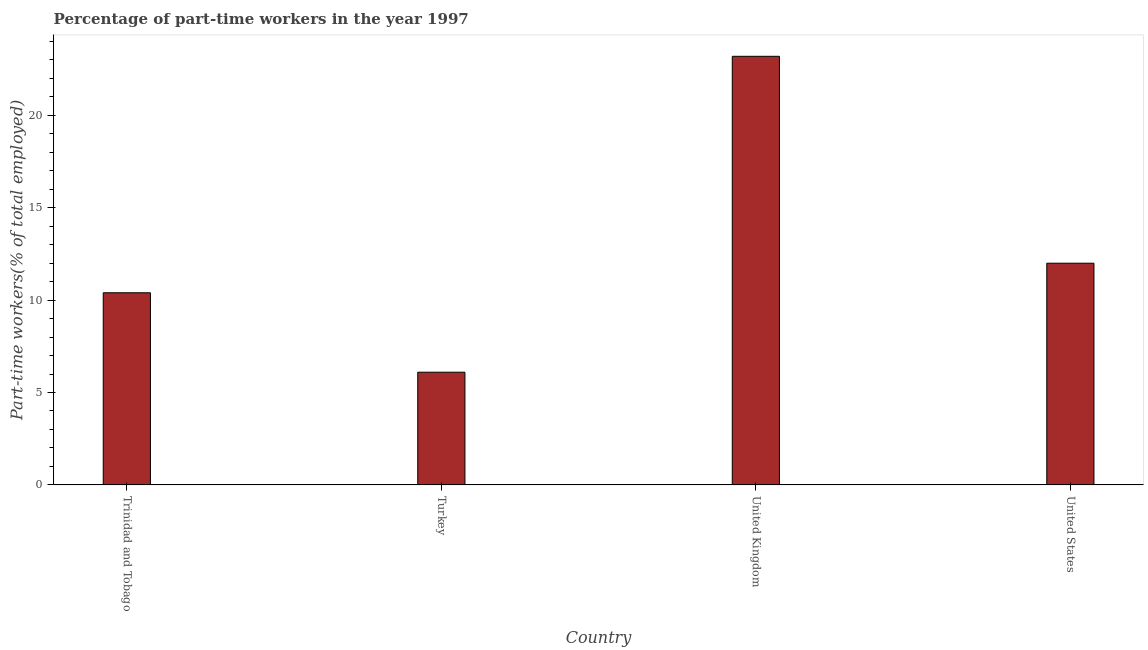Does the graph contain any zero values?
Keep it short and to the point. No. Does the graph contain grids?
Your answer should be very brief. No. What is the title of the graph?
Make the answer very short. Percentage of part-time workers in the year 1997. What is the label or title of the X-axis?
Provide a short and direct response. Country. What is the label or title of the Y-axis?
Give a very brief answer. Part-time workers(% of total employed). What is the percentage of part-time workers in Trinidad and Tobago?
Keep it short and to the point. 10.4. Across all countries, what is the maximum percentage of part-time workers?
Ensure brevity in your answer.  23.2. Across all countries, what is the minimum percentage of part-time workers?
Provide a short and direct response. 6.1. In which country was the percentage of part-time workers maximum?
Keep it short and to the point. United Kingdom. In which country was the percentage of part-time workers minimum?
Your answer should be very brief. Turkey. What is the sum of the percentage of part-time workers?
Offer a very short reply. 51.7. What is the average percentage of part-time workers per country?
Your response must be concise. 12.93. What is the median percentage of part-time workers?
Your answer should be compact. 11.2. What is the ratio of the percentage of part-time workers in Turkey to that in United States?
Your response must be concise. 0.51. Is the percentage of part-time workers in Turkey less than that in United Kingdom?
Keep it short and to the point. Yes. Is the difference between the percentage of part-time workers in Turkey and United Kingdom greater than the difference between any two countries?
Your response must be concise. Yes. What is the difference between the highest and the second highest percentage of part-time workers?
Provide a short and direct response. 11.2. Is the sum of the percentage of part-time workers in Turkey and United Kingdom greater than the maximum percentage of part-time workers across all countries?
Ensure brevity in your answer.  Yes. What is the difference between the highest and the lowest percentage of part-time workers?
Provide a short and direct response. 17.1. In how many countries, is the percentage of part-time workers greater than the average percentage of part-time workers taken over all countries?
Provide a short and direct response. 1. Are all the bars in the graph horizontal?
Offer a terse response. No. What is the Part-time workers(% of total employed) of Trinidad and Tobago?
Offer a terse response. 10.4. What is the Part-time workers(% of total employed) in Turkey?
Provide a succinct answer. 6.1. What is the Part-time workers(% of total employed) of United Kingdom?
Offer a very short reply. 23.2. What is the Part-time workers(% of total employed) in United States?
Offer a very short reply. 12. What is the difference between the Part-time workers(% of total employed) in Turkey and United Kingdom?
Ensure brevity in your answer.  -17.1. What is the difference between the Part-time workers(% of total employed) in United Kingdom and United States?
Make the answer very short. 11.2. What is the ratio of the Part-time workers(% of total employed) in Trinidad and Tobago to that in Turkey?
Ensure brevity in your answer.  1.71. What is the ratio of the Part-time workers(% of total employed) in Trinidad and Tobago to that in United Kingdom?
Provide a short and direct response. 0.45. What is the ratio of the Part-time workers(% of total employed) in Trinidad and Tobago to that in United States?
Your answer should be very brief. 0.87. What is the ratio of the Part-time workers(% of total employed) in Turkey to that in United Kingdom?
Keep it short and to the point. 0.26. What is the ratio of the Part-time workers(% of total employed) in Turkey to that in United States?
Offer a very short reply. 0.51. What is the ratio of the Part-time workers(% of total employed) in United Kingdom to that in United States?
Your response must be concise. 1.93. 